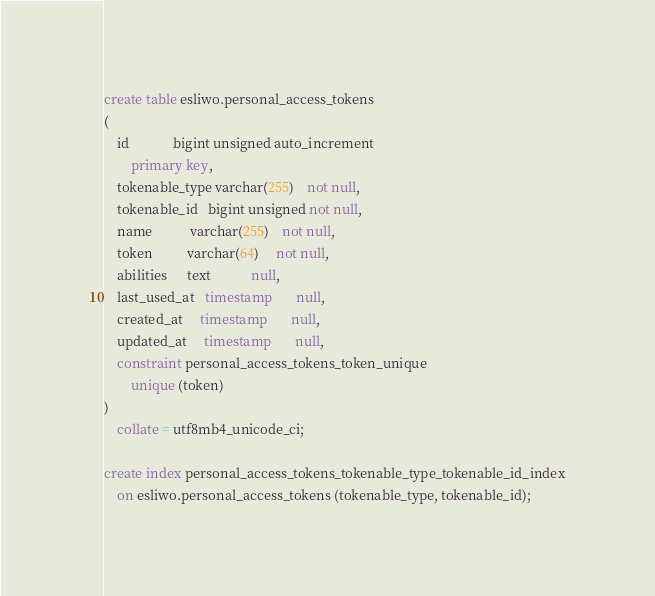Convert code to text. <code><loc_0><loc_0><loc_500><loc_500><_SQL_>create table esliwo.personal_access_tokens
(
    id             bigint unsigned auto_increment
        primary key,
    tokenable_type varchar(255)    not null,
    tokenable_id   bigint unsigned not null,
    name           varchar(255)    not null,
    token          varchar(64)     not null,
    abilities      text            null,
    last_used_at   timestamp       null,
    created_at     timestamp       null,
    updated_at     timestamp       null,
    constraint personal_access_tokens_token_unique
        unique (token)
)
    collate = utf8mb4_unicode_ci;

create index personal_access_tokens_tokenable_type_tokenable_id_index
    on esliwo.personal_access_tokens (tokenable_type, tokenable_id);

</code> 